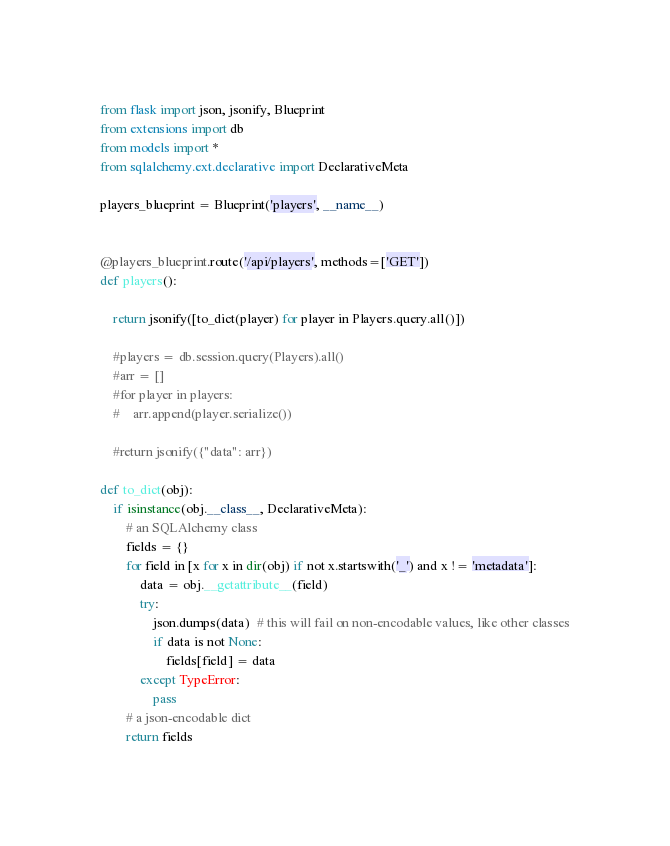Convert code to text. <code><loc_0><loc_0><loc_500><loc_500><_Python_>
from flask import json, jsonify, Blueprint
from extensions import db
from models import *
from sqlalchemy.ext.declarative import DeclarativeMeta

players_blueprint = Blueprint('players', __name__)


@players_blueprint.route('/api/players', methods=['GET'])
def players():

    return jsonify([to_dict(player) for player in Players.query.all()])

    #players = db.session.query(Players).all()
    #arr = []
    #for player in players:
    #    arr.append(player.serialize())

    #return jsonify({"data": arr})

def to_dict(obj):
    if isinstance(obj.__class__, DeclarativeMeta):
        # an SQLAlchemy class
        fields = {}
        for field in [x for x in dir(obj) if not x.startswith('_') and x != 'metadata']:
            data = obj.__getattribute__(field)
            try:
                json.dumps(data)  # this will fail on non-encodable values, like other classes
                if data is not None:
                    fields[field] = data
            except TypeError:
                pass
        # a json-encodable dict
        return fields</code> 